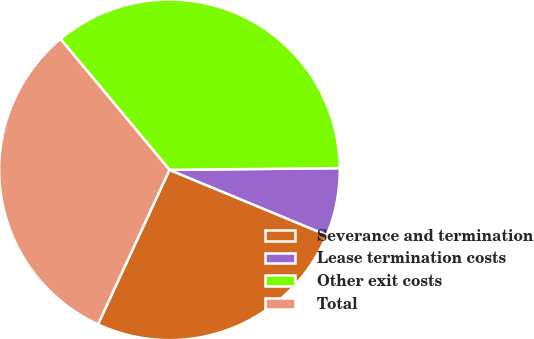Convert chart to OTSL. <chart><loc_0><loc_0><loc_500><loc_500><pie_chart><fcel>Severance and termination<fcel>Lease termination costs<fcel>Other exit costs<fcel>Total<nl><fcel>25.64%<fcel>6.41%<fcel>35.9%<fcel>32.05%<nl></chart> 